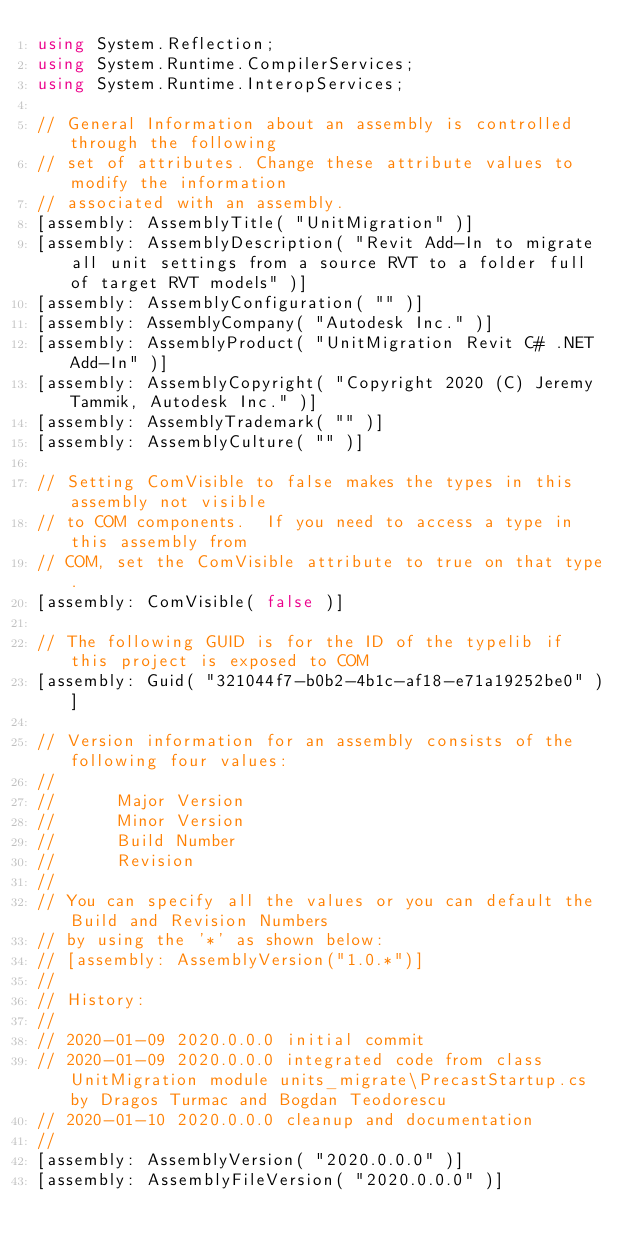Convert code to text. <code><loc_0><loc_0><loc_500><loc_500><_C#_>using System.Reflection;
using System.Runtime.CompilerServices;
using System.Runtime.InteropServices;

// General Information about an assembly is controlled through the following
// set of attributes. Change these attribute values to modify the information
// associated with an assembly.
[assembly: AssemblyTitle( "UnitMigration" )]
[assembly: AssemblyDescription( "Revit Add-In to migrate all unit settings from a source RVT to a folder full of target RVT models" )]
[assembly: AssemblyConfiguration( "" )]
[assembly: AssemblyCompany( "Autodesk Inc." )]
[assembly: AssemblyProduct( "UnitMigration Revit C# .NET Add-In" )]
[assembly: AssemblyCopyright( "Copyright 2020 (C) Jeremy Tammik, Autodesk Inc." )]
[assembly: AssemblyTrademark( "" )]
[assembly: AssemblyCulture( "" )]

// Setting ComVisible to false makes the types in this assembly not visible
// to COM components.  If you need to access a type in this assembly from
// COM, set the ComVisible attribute to true on that type.
[assembly: ComVisible( false )]

// The following GUID is for the ID of the typelib if this project is exposed to COM
[assembly: Guid( "321044f7-b0b2-4b1c-af18-e71a19252be0" )]

// Version information for an assembly consists of the following four values:
//
//      Major Version
//      Minor Version
//      Build Number
//      Revision
//
// You can specify all the values or you can default the Build and Revision Numbers
// by using the '*' as shown below:
// [assembly: AssemblyVersion("1.0.*")]
//
// History:
//
// 2020-01-09 2020.0.0.0 initial commit
// 2020-01-09 2020.0.0.0 integrated code from class UnitMigration module units_migrate\PrecastStartup.cs by Dragos Turmac and Bogdan Teodorescu 
// 2020-01-10 2020.0.0.0 cleanup and documentation
//
[assembly: AssemblyVersion( "2020.0.0.0" )]
[assembly: AssemblyFileVersion( "2020.0.0.0" )]
</code> 